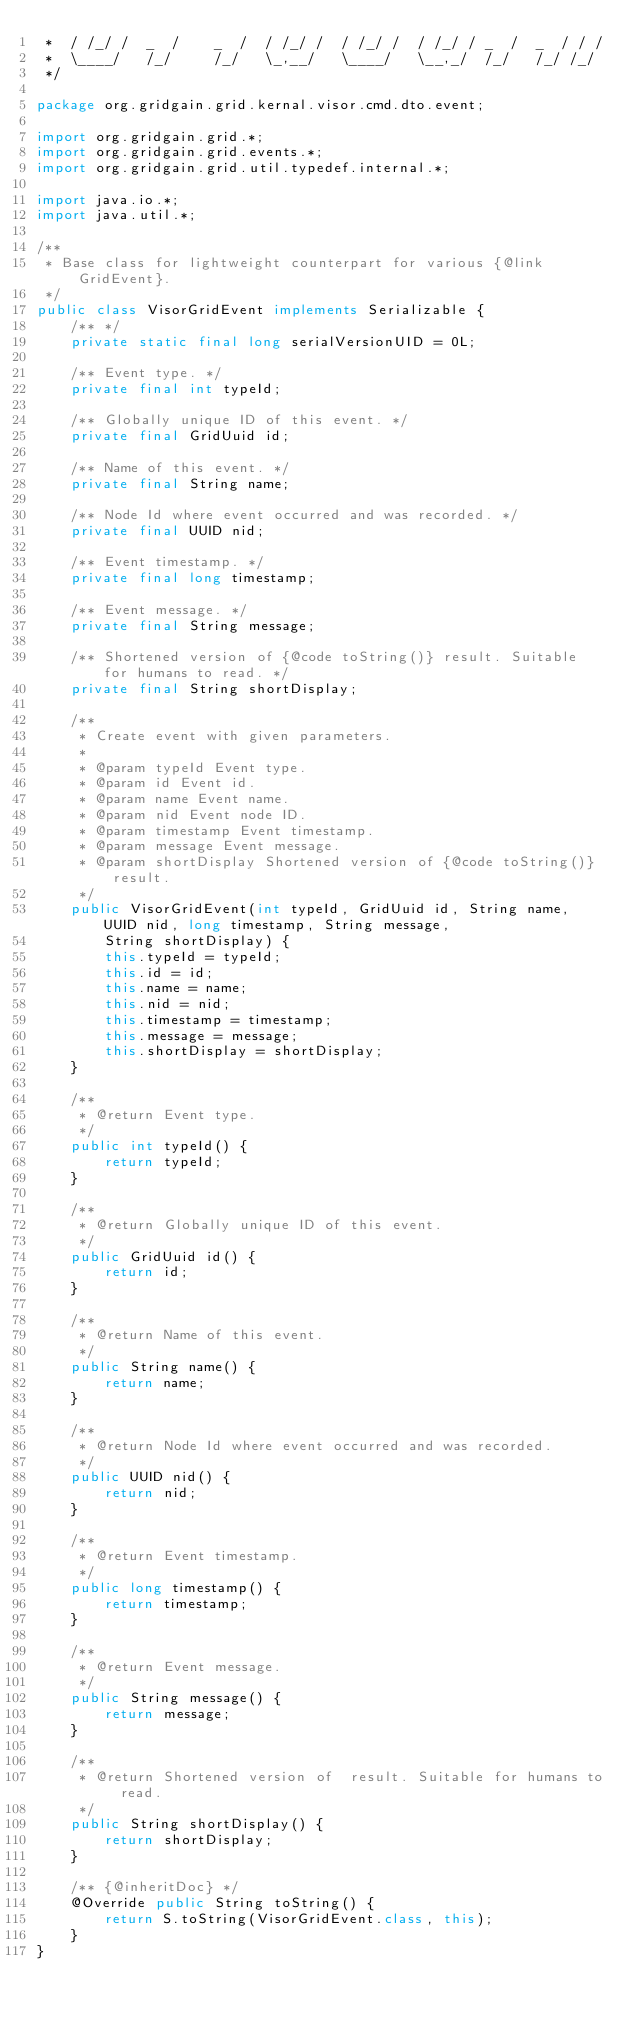<code> <loc_0><loc_0><loc_500><loc_500><_Java_> *  / /_/ /  _  /    _  /  / /_/ /  / /_/ /  / /_/ / _  /  _  / / /
 *  \____/   /_/     /_/   \_,__/   \____/   \__,_/  /_/   /_/ /_/
 */

package org.gridgain.grid.kernal.visor.cmd.dto.event;

import org.gridgain.grid.*;
import org.gridgain.grid.events.*;
import org.gridgain.grid.util.typedef.internal.*;

import java.io.*;
import java.util.*;

/**
 * Base class for lightweight counterpart for various {@link GridEvent}.
 */
public class VisorGridEvent implements Serializable {
    /** */
    private static final long serialVersionUID = 0L;

    /** Event type. */
    private final int typeId;

    /** Globally unique ID of this event. */
    private final GridUuid id;

    /** Name of this event. */
    private final String name;

    /** Node Id where event occurred and was recorded. */
    private final UUID nid;

    /** Event timestamp. */
    private final long timestamp;

    /** Event message. */
    private final String message;

    /** Shortened version of {@code toString()} result. Suitable for humans to read. */
    private final String shortDisplay;

    /**
     * Create event with given parameters.
     *
     * @param typeId Event type.
     * @param id Event id.
     * @param name Event name.
     * @param nid Event node ID.
     * @param timestamp Event timestamp.
     * @param message Event message.
     * @param shortDisplay Shortened version of {@code toString()} result.
     */
    public VisorGridEvent(int typeId, GridUuid id, String name, UUID nid, long timestamp, String message,
        String shortDisplay) {
        this.typeId = typeId;
        this.id = id;
        this.name = name;
        this.nid = nid;
        this.timestamp = timestamp;
        this.message = message;
        this.shortDisplay = shortDisplay;
    }

    /**
     * @return Event type.
     */
    public int typeId() {
        return typeId;
    }

    /**
     * @return Globally unique ID of this event.
     */
    public GridUuid id() {
        return id;
    }

    /**
     * @return Name of this event.
     */
    public String name() {
        return name;
    }

    /**
     * @return Node Id where event occurred and was recorded.
     */
    public UUID nid() {
        return nid;
    }

    /**
     * @return Event timestamp.
     */
    public long timestamp() {
        return timestamp;
    }

    /**
     * @return Event message.
     */
    public String message() {
        return message;
    }

    /**
     * @return Shortened version of  result. Suitable for humans to read.
     */
    public String shortDisplay() {
        return shortDisplay;
    }

    /** {@inheritDoc} */
    @Override public String toString() {
        return S.toString(VisorGridEvent.class, this);
    }
}
</code> 